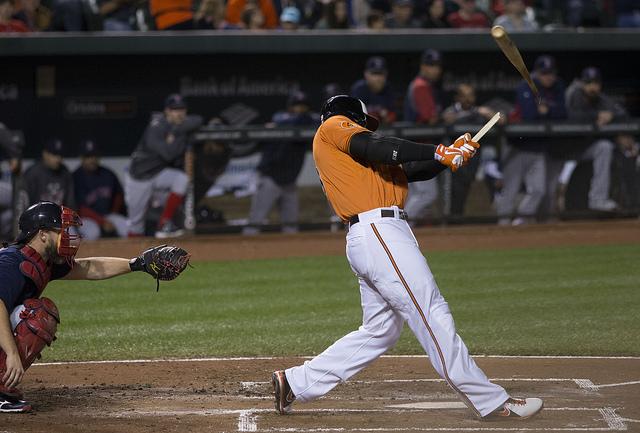Did the batter just get a hit?
Answer briefly. Yes. What color is the stripe?
Keep it brief. Orange. Where is the bat?
Concise answer only. In air. Which foot is furthest forward?
Quick response, please. Right. What color is his jersey?
Write a very short answer. Orange. What color is the catcher's mitt?
Write a very short answer. Black. What brand of shoes is the batter wearing?
Answer briefly. Nike. 